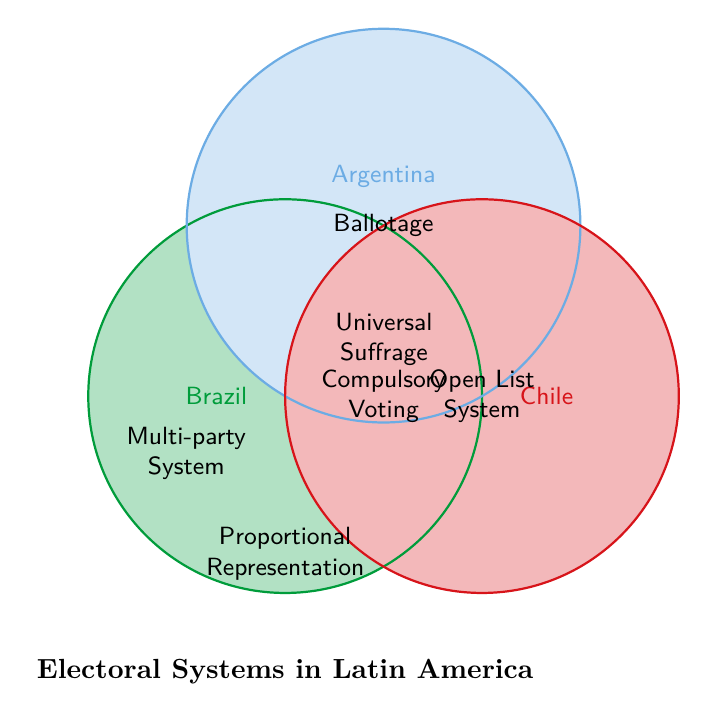What are the unique electoral systems of Brazil? By looking at the area of the Venn Diagram labeled specifically for Brazil, we can identify: Proportional Representation, Electronic Voting, Two-Round System, Chamber of Deputies, and Coalitions.
Answer: Proportional Representation, Electronic Voting, Two-Round System, Chamber of Deputies, Coalitions Which countries have a multi-party system in their electoral systems? The Venn Diagram shows that the multi-party system is placed in the overlapping area of all three circles, indicating that Brazil, Argentina, and Chile all have a multi-party system in their electoral systems.
Answer: Brazil, Argentina, and Chile What is shared between Argentina and Chile that Brazil doesn't have? By referring to the overlapping section between Argentina and Chile circles, excluding the larger overlapping section of all three circles, we can see Open List System for Chile and Ballotage for Argentina are not shared with Brazil.
Answer: Ballotage and Open List System Which electoral system is unique to Chile and not shared with either Brazil or Argentina? Looking at the section of the Venn Diagram that is exclusive to the Chile circle, it highlights Binomial System (pre-2015) and Concertación as unique to Chile.
Answer: Binomial System (pre-2015) and Concertación Compare the number of unique electoral systems between Brazil and Argentina. For Brazil, the unique electoral systems are Proportional Representation, Electronic Voting, Two-Round System, Chamber of Deputies, and Coalitions (total: 5). For Argentina, the unique electoral systems are Ballotage, Peronism, Concurrent Elections, National Electoral Court, and Kirchnerism (total: 5). Hence, they both have the same number of unique electoral systems.
Answer: Same number of unique systems Which specific electoral features are common to all three countries? The Venn Diagram shows the central overlapping area of all three circles for features common to Brazil, Argentina, and Chile: Universal Suffrage, Compulsory Voting, Presidential System, Legislative Elections, Independent Electoral Bodies, and Multi-party System.
Answer: Universal Suffrage, Compulsory Voting, Presidential System, Legislative Elections, Independent Electoral Bodies, Multi-party System What system is present in both Brazil and Argentina but not in Chile? Referring to the overlapping area between the Brazil and Argentina circles, but excluding the central overlap with Chile, we observe Proportional Representation.
Answer: Proportional Representation 